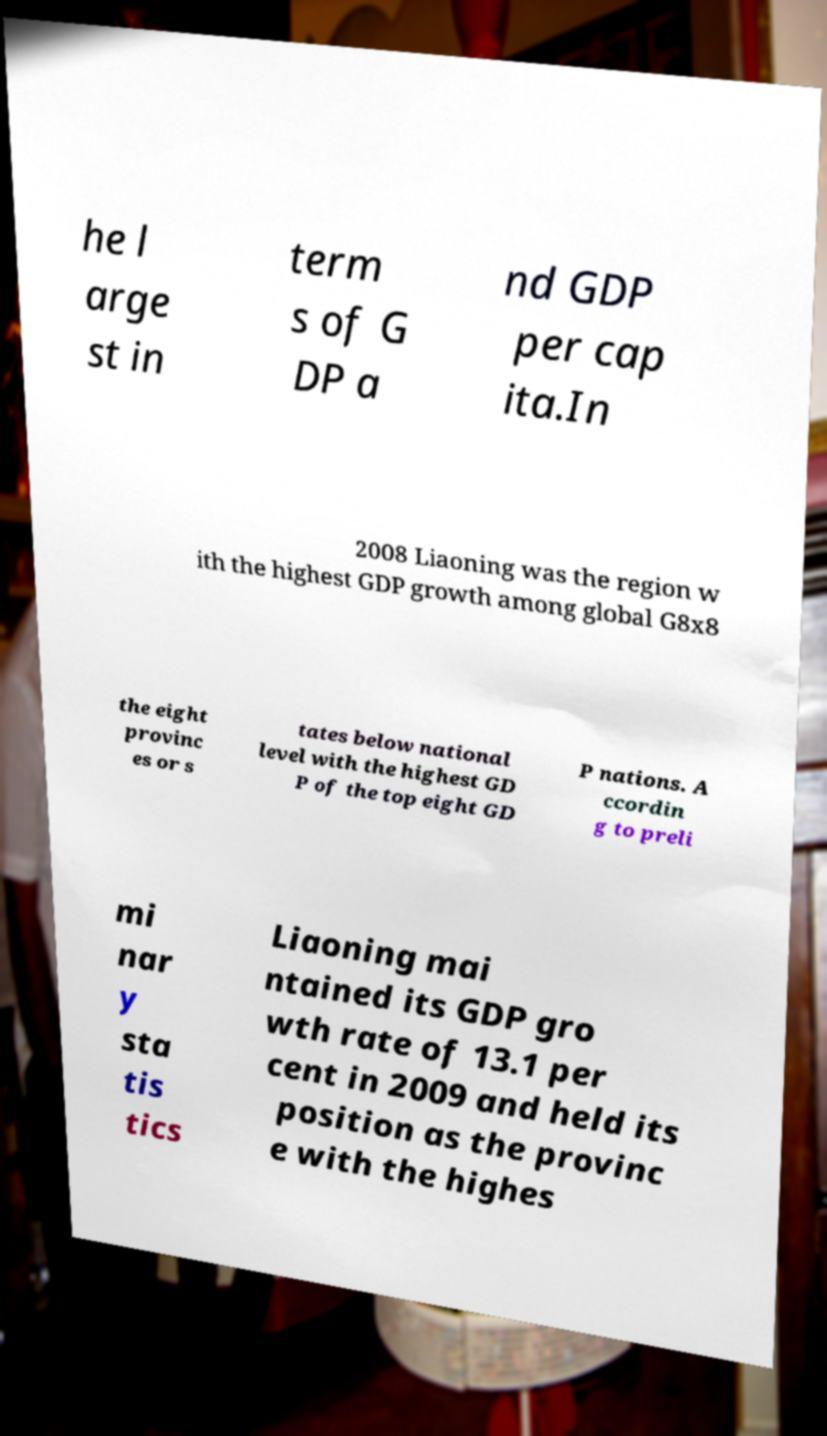Can you read and provide the text displayed in the image?This photo seems to have some interesting text. Can you extract and type it out for me? he l arge st in term s of G DP a nd GDP per cap ita.In 2008 Liaoning was the region w ith the highest GDP growth among global G8x8 the eight provinc es or s tates below national level with the highest GD P of the top eight GD P nations. A ccordin g to preli mi nar y sta tis tics Liaoning mai ntained its GDP gro wth rate of 13.1 per cent in 2009 and held its position as the provinc e with the highes 